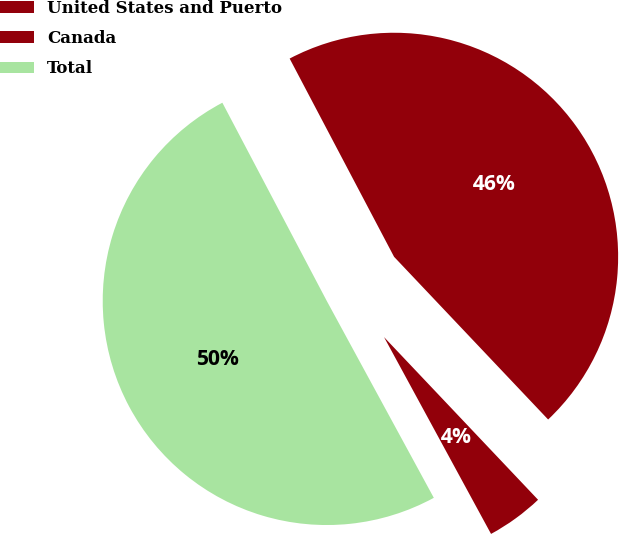Convert chart. <chart><loc_0><loc_0><loc_500><loc_500><pie_chart><fcel>United States and Puerto<fcel>Canada<fcel>Total<nl><fcel>45.65%<fcel>4.14%<fcel>50.21%<nl></chart> 